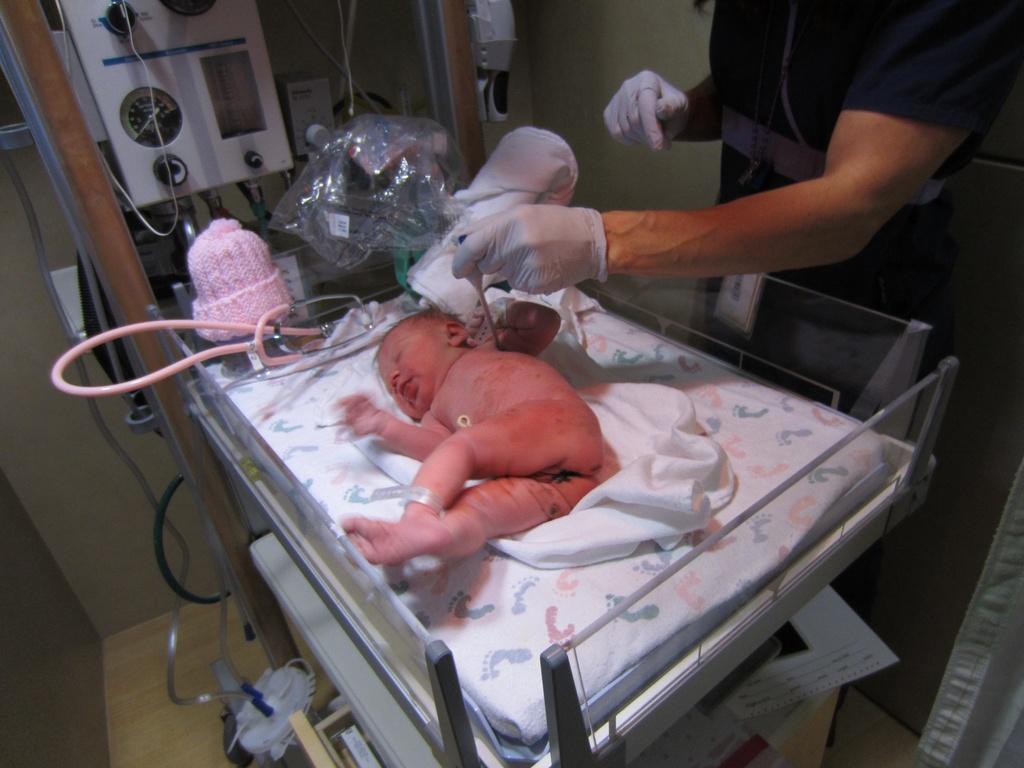In one or two sentences, can you explain what this image depicts? A little baby is there on the bed, on the right side a person is there, this person wore hand gloves. 